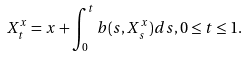Convert formula to latex. <formula><loc_0><loc_0><loc_500><loc_500>X _ { t } ^ { x } = x + \int _ { 0 } ^ { t } b ( s , X _ { s } ^ { x } ) d s , 0 \leq t \leq 1 .</formula> 